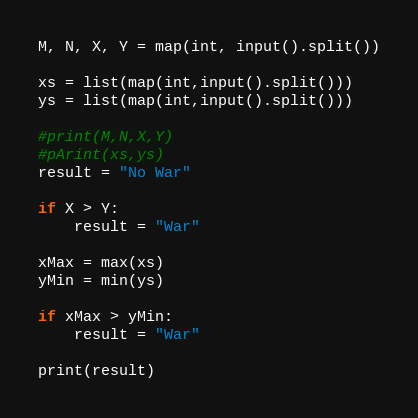<code> <loc_0><loc_0><loc_500><loc_500><_Python_>M, N, X, Y = map(int, input().split())

xs = list(map(int,input().split()))
ys = list(map(int,input().split()))

#print(M,N,X,Y)
#pArint(xs,ys)
result = "No War"

if X > Y:
    result = "War"

xMax = max(xs)
yMin = min(ys)

if xMax > yMin:
    result = "War"

print(result)

</code> 